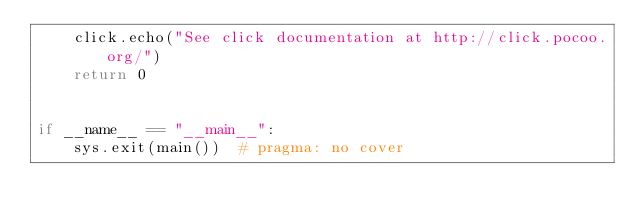<code> <loc_0><loc_0><loc_500><loc_500><_Python_>    click.echo("See click documentation at http://click.pocoo.org/")
    return 0


if __name__ == "__main__":
    sys.exit(main())  # pragma: no cover
</code> 